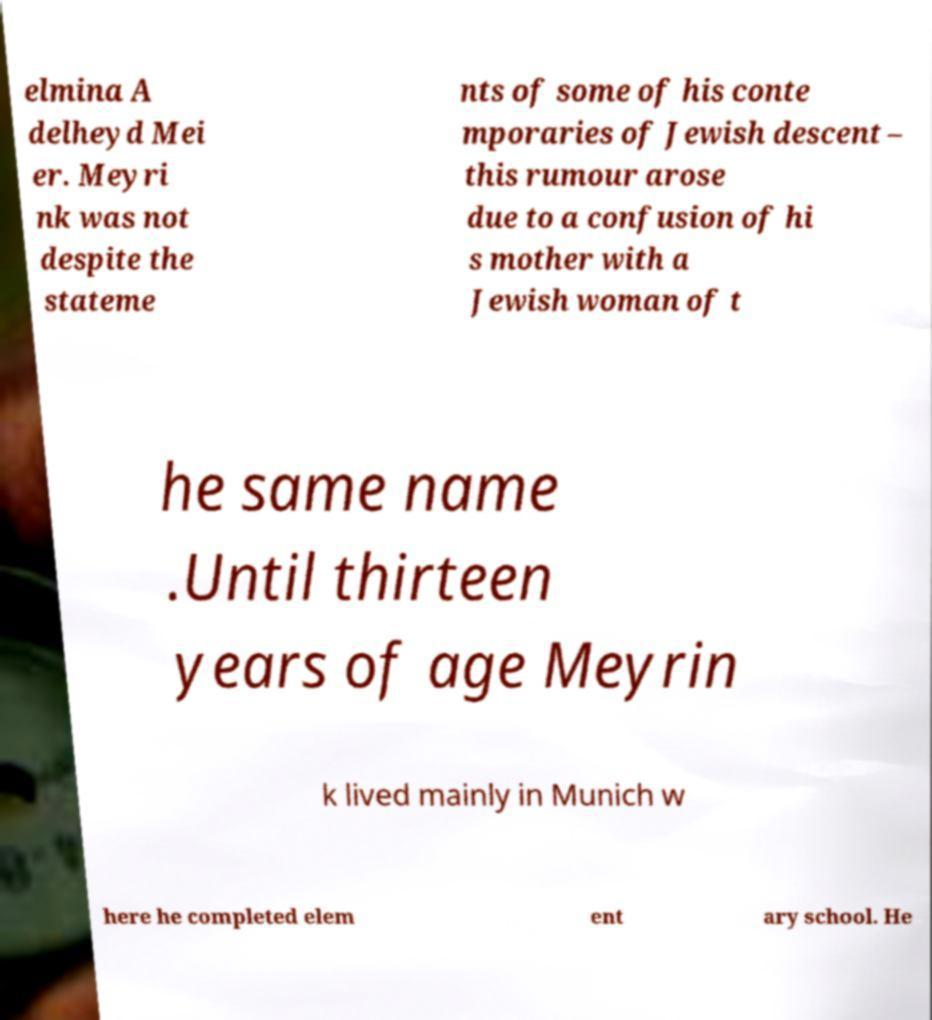There's text embedded in this image that I need extracted. Can you transcribe it verbatim? elmina A delheyd Mei er. Meyri nk was not despite the stateme nts of some of his conte mporaries of Jewish descent – this rumour arose due to a confusion of hi s mother with a Jewish woman of t he same name .Until thirteen years of age Meyrin k lived mainly in Munich w here he completed elem ent ary school. He 